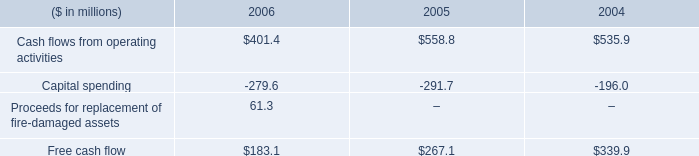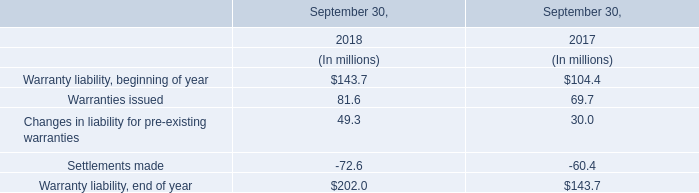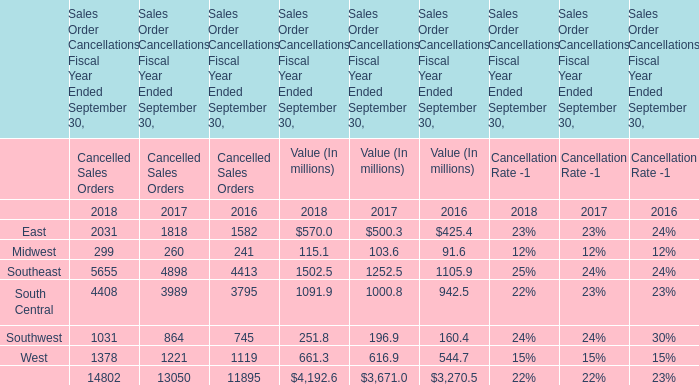What will Value of the total Cancelled Sales Orders be like in 2019 if it develops with the same increasing rate as current? (in million) 
Computations: (4192.6 * (1 + ((4192.6 - 3671.0) / 3671.0)))
Answer: 4788.31238. 